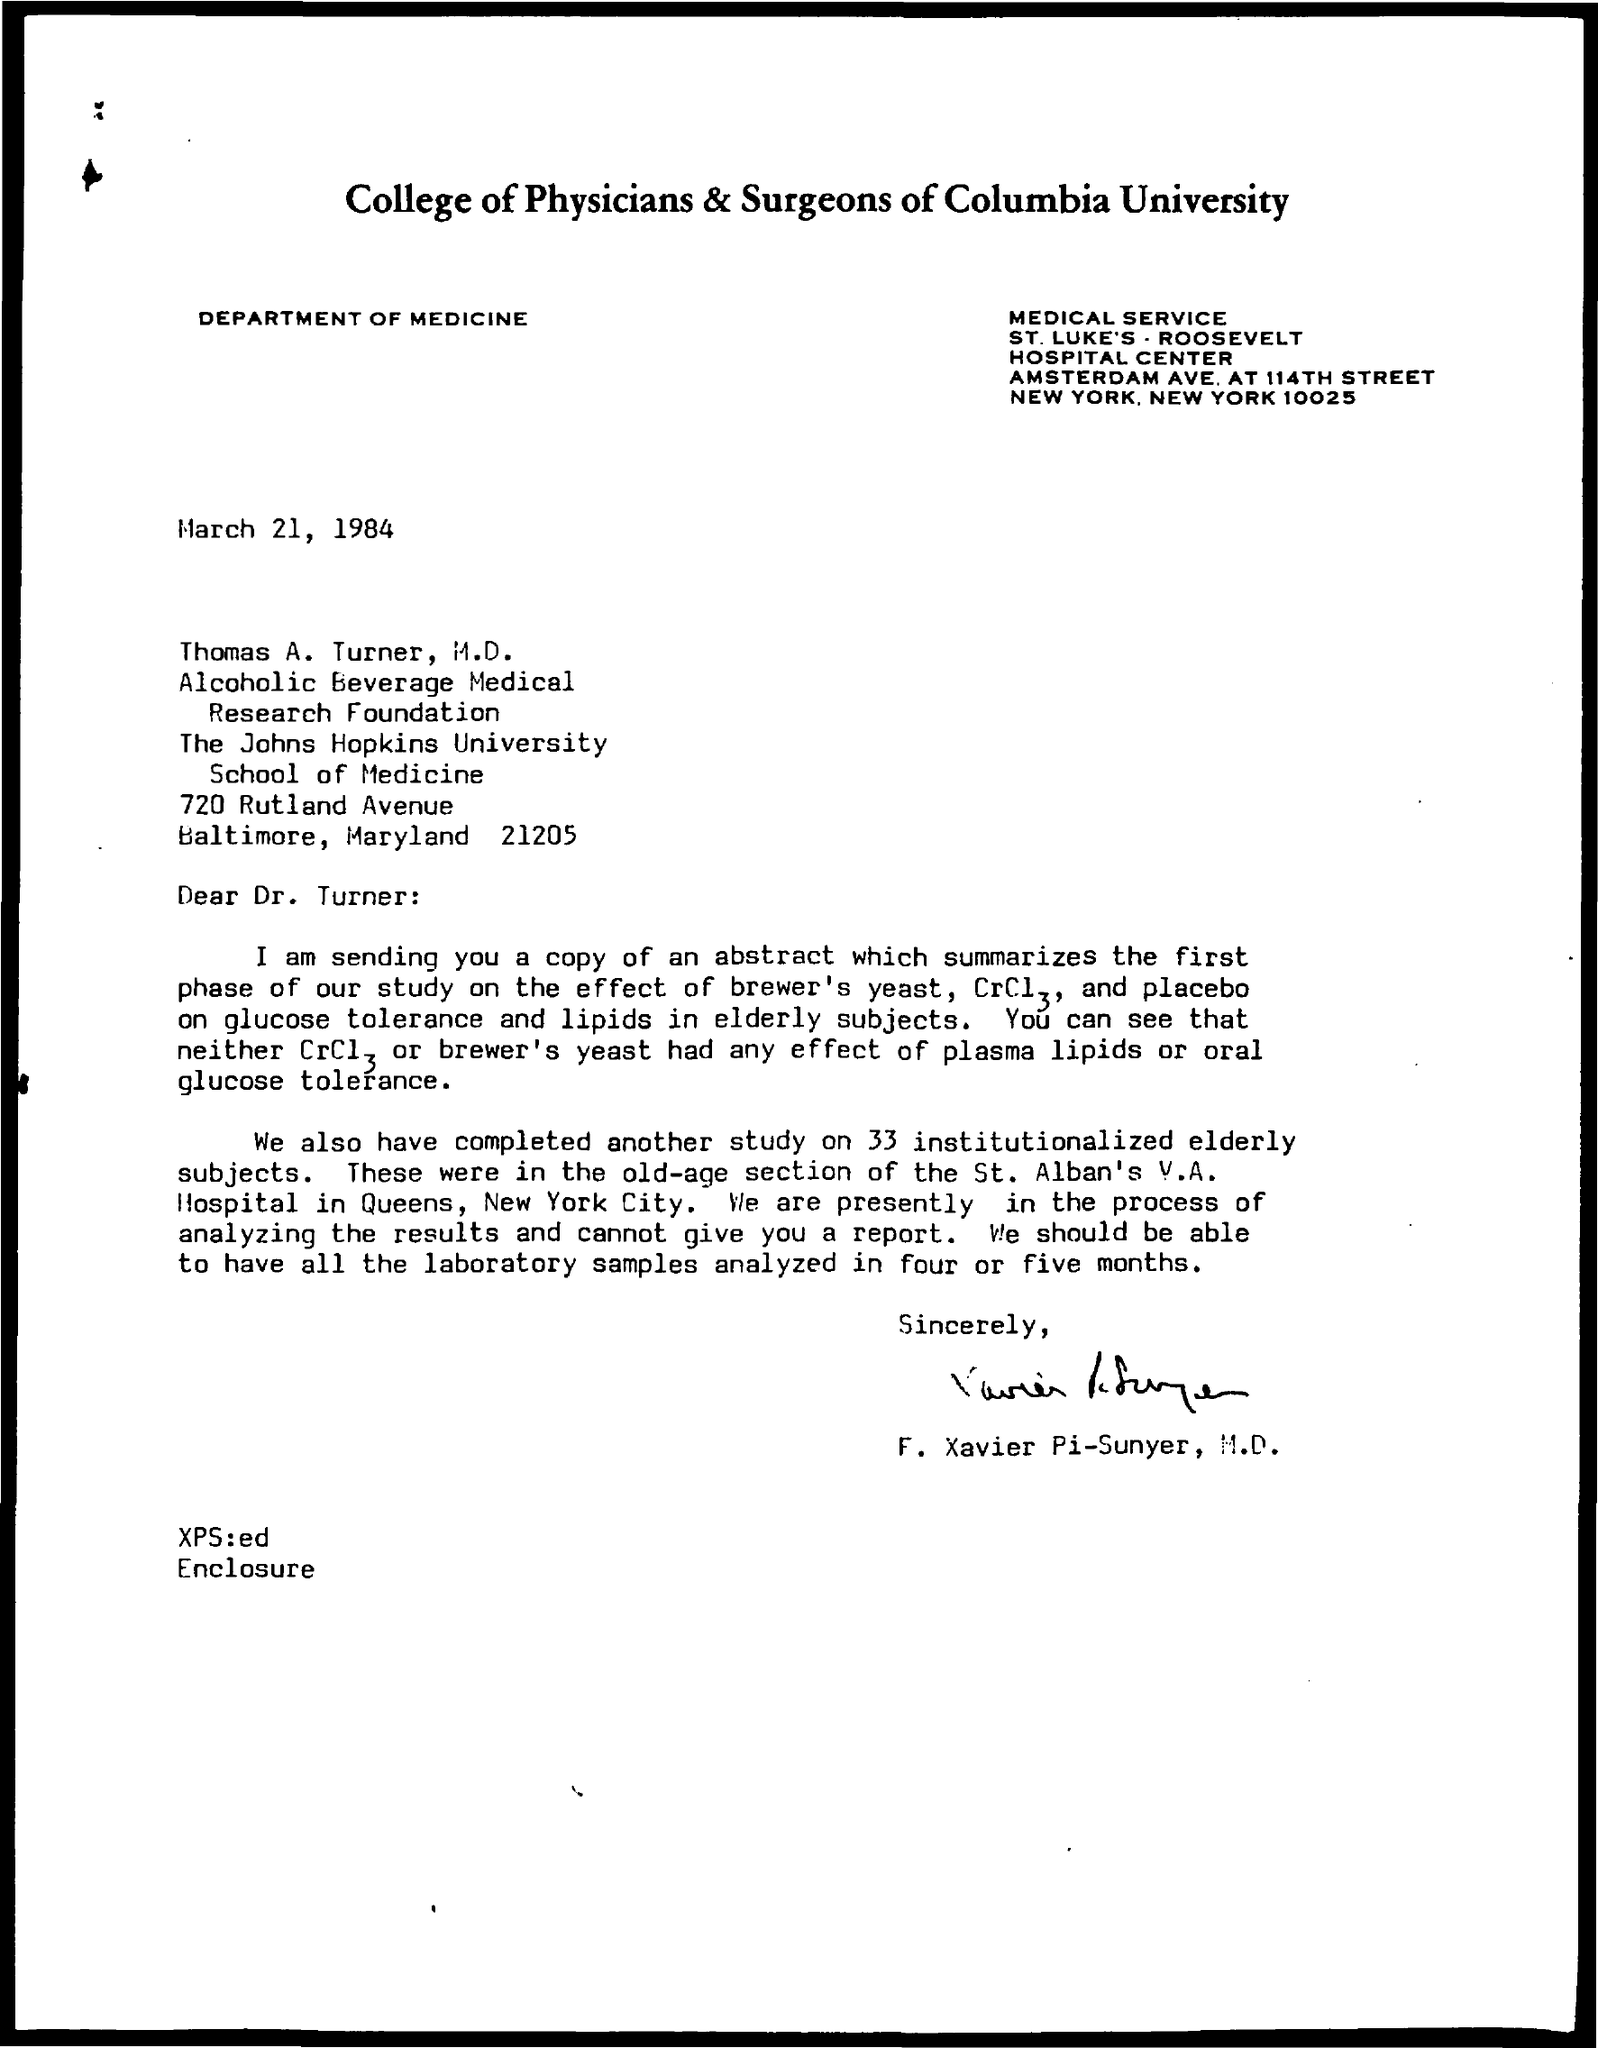Draw attention to some important aspects in this diagram. The document mentions the Department of Medicine. The document mentions the College of Physicians & Surgeons of Columbia University. 